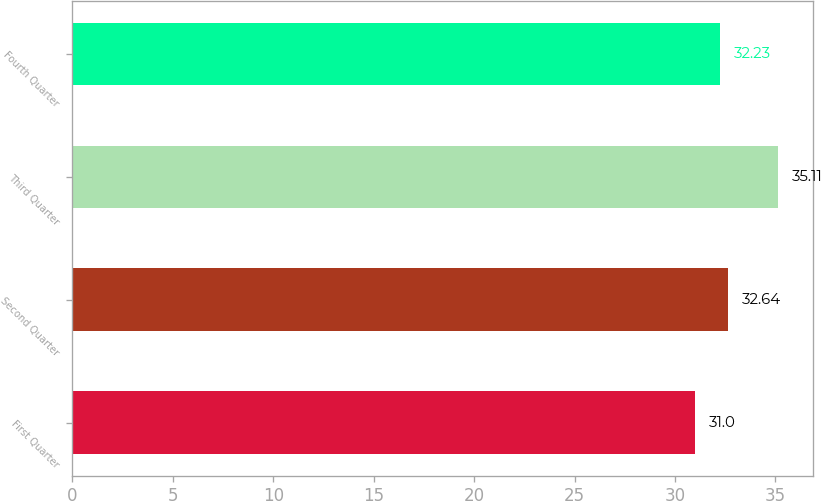Convert chart to OTSL. <chart><loc_0><loc_0><loc_500><loc_500><bar_chart><fcel>First Quarter<fcel>Second Quarter<fcel>Third Quarter<fcel>Fourth Quarter<nl><fcel>31<fcel>32.64<fcel>35.11<fcel>32.23<nl></chart> 